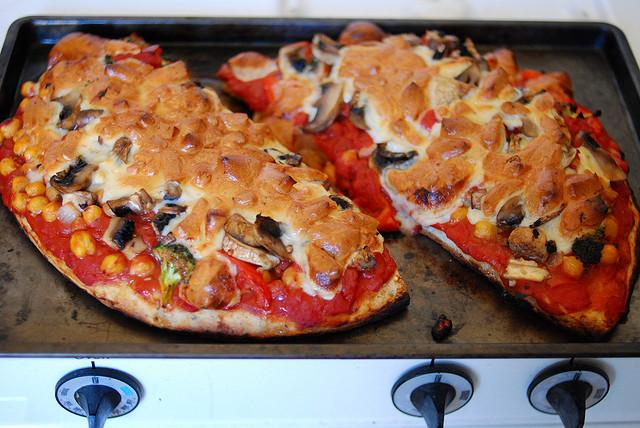What is under the pizza?
Keep it brief. Pan. What is holding the pizza?
Write a very short answer. Pan. Was this a take out pizza?
Give a very brief answer. No. Is there corn on this pizza?
Quick response, please. Yes. How many slices is the pizza cut into?
Give a very brief answer. 2. 